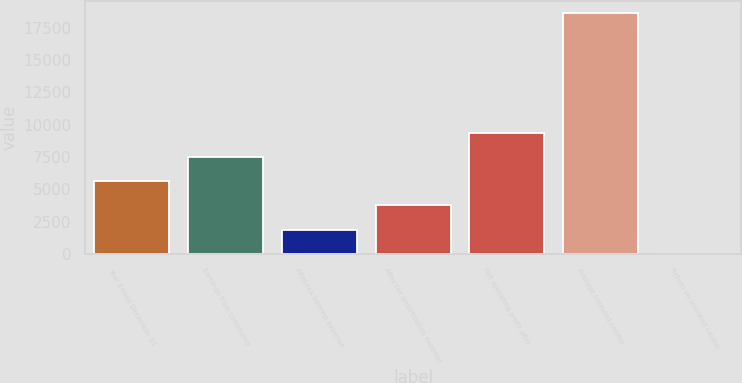Convert chart. <chart><loc_0><loc_0><loc_500><loc_500><bar_chart><fcel>Year Ended December 31<fcel>Earnings from continuing<fcel>After-tax interest expense<fcel>After-tax amortization expense<fcel>Net operating profit after<fcel>Average invested capital<fcel>Return on invested capital<nl><fcel>5612.47<fcel>7478.26<fcel>1880.89<fcel>3746.68<fcel>9344.05<fcel>18673<fcel>15.1<nl></chart> 